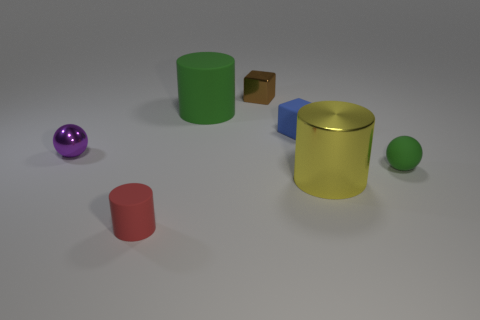Subtract all green cylinders. How many cylinders are left? 2 Subtract all tiny red rubber cylinders. How many cylinders are left? 2 Add 2 yellow rubber balls. How many objects exist? 9 Subtract all brown blocks. How many red cylinders are left? 1 Add 1 tiny rubber spheres. How many tiny rubber spheres are left? 2 Add 2 small matte things. How many small matte things exist? 5 Subtract 0 brown balls. How many objects are left? 7 Subtract all blocks. How many objects are left? 5 Subtract 1 cubes. How many cubes are left? 1 Subtract all red blocks. Subtract all yellow cylinders. How many blocks are left? 2 